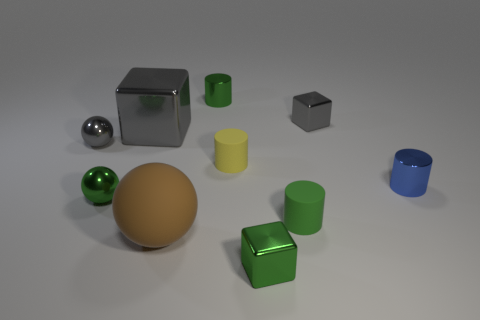Does the gray ball have the same size as the green shiny cylinder?
Give a very brief answer. Yes. There is a big metal thing left of the tiny metallic block that is behind the tiny green sphere; what is its color?
Provide a succinct answer. Gray. The large metal object is what color?
Make the answer very short. Gray. Are there any small rubber cylinders of the same color as the large cube?
Your response must be concise. No. Do the metal object that is to the left of the green metallic sphere and the large cube have the same color?
Offer a very short reply. Yes. What number of things are green objects that are behind the big matte ball or tiny gray metal blocks?
Provide a short and direct response. 4. Are there any green shiny cylinders on the left side of the large gray block?
Offer a very short reply. No. There is a sphere that is the same color as the big metal cube; what material is it?
Ensure brevity in your answer.  Metal. Do the tiny green object that is to the left of the big brown ball and the gray ball have the same material?
Give a very brief answer. Yes. Are there any big rubber spheres that are behind the thing that is right of the small block behind the blue object?
Your response must be concise. No. 